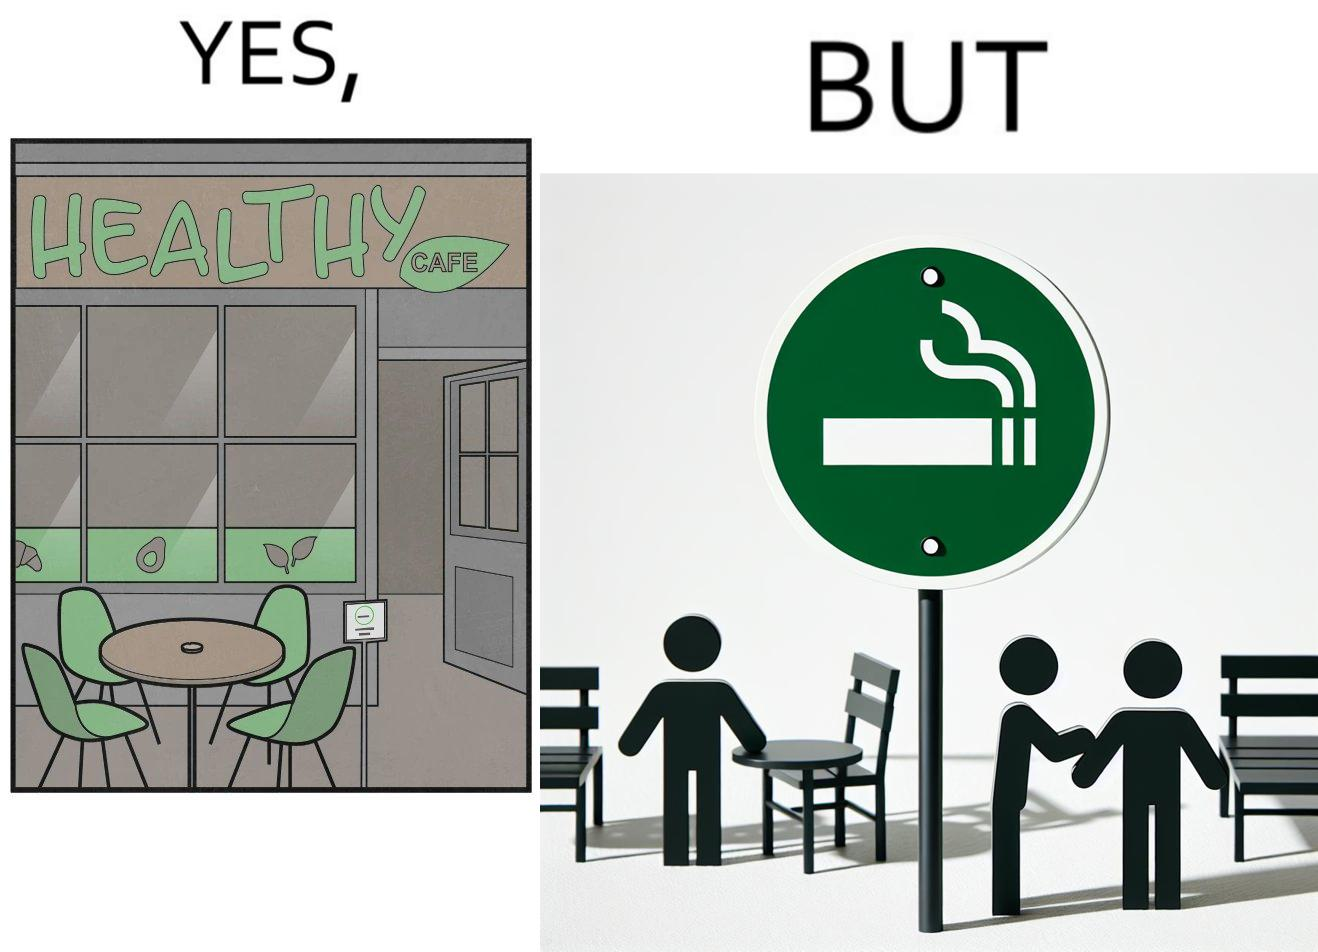What is shown in this image? This image is funny because an eatery that calls itself the "healthy" cafe also has a smoking area, which is not very "healthy". If it really was a healthy cafe, it would not have a smoking area as smoking is injurious to health. Satire on the behavior of humans - both those that operate this cafe who made the decision of allowing smoking and creating a designated smoking area, and those that visit this healthy cafe to become "healthy", but then also indulge in very unhealthy habits simultaneously. 